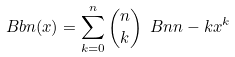Convert formula to latex. <formula><loc_0><loc_0><loc_500><loc_500>\ B b { n } ( x ) = \sum _ { k = 0 } ^ { n } \binom { n } { k } \ B n { n - k } x ^ { k }</formula> 